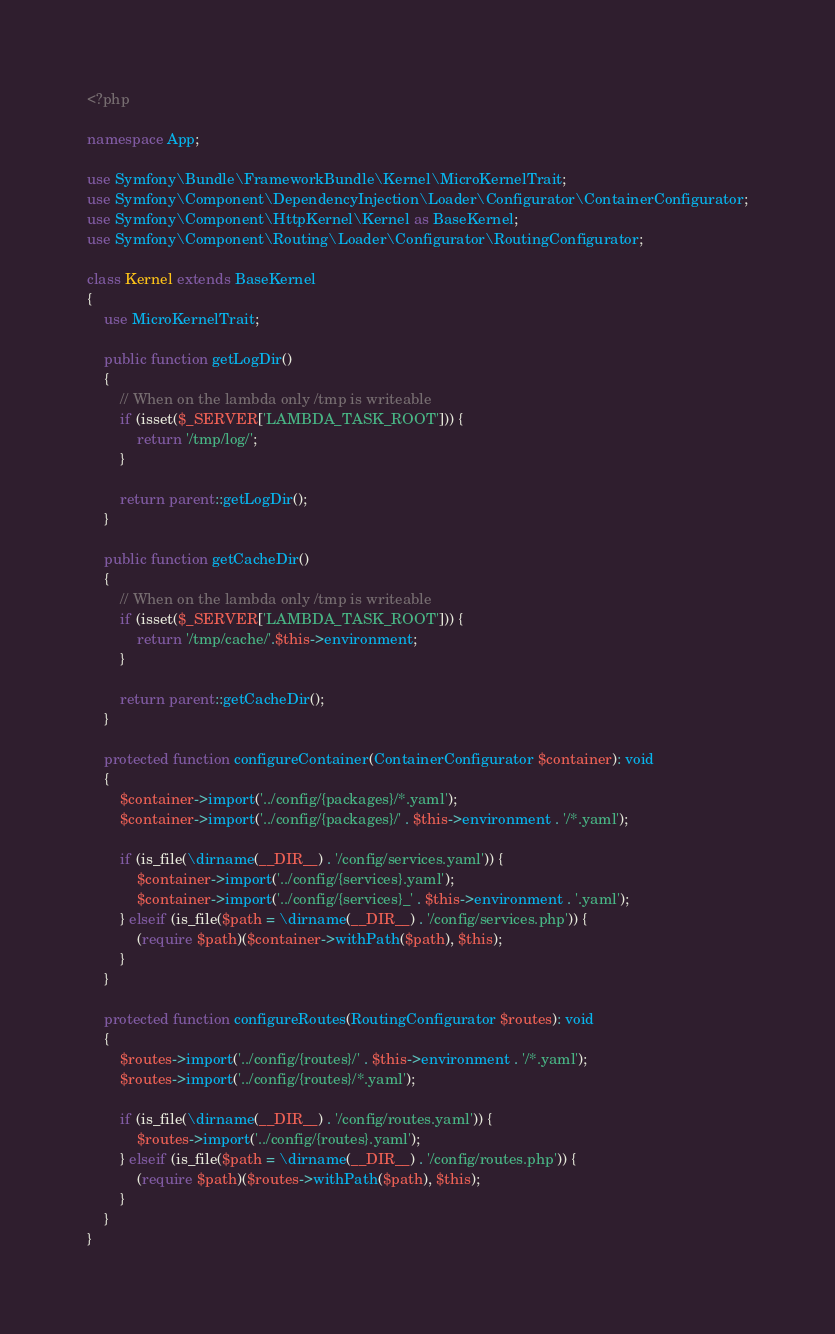Convert code to text. <code><loc_0><loc_0><loc_500><loc_500><_PHP_><?php

namespace App;

use Symfony\Bundle\FrameworkBundle\Kernel\MicroKernelTrait;
use Symfony\Component\DependencyInjection\Loader\Configurator\ContainerConfigurator;
use Symfony\Component\HttpKernel\Kernel as BaseKernel;
use Symfony\Component\Routing\Loader\Configurator\RoutingConfigurator;

class Kernel extends BaseKernel
{
    use MicroKernelTrait;

    public function getLogDir()
    {
        // When on the lambda only /tmp is writeable
        if (isset($_SERVER['LAMBDA_TASK_ROOT'])) {
            return '/tmp/log/';
        }

        return parent::getLogDir();
    }

    public function getCacheDir()
    {
        // When on the lambda only /tmp is writeable
        if (isset($_SERVER['LAMBDA_TASK_ROOT'])) {
            return '/tmp/cache/'.$this->environment;
        }

        return parent::getCacheDir();
    }

    protected function configureContainer(ContainerConfigurator $container): void
    {
        $container->import('../config/{packages}/*.yaml');
        $container->import('../config/{packages}/' . $this->environment . '/*.yaml');

        if (is_file(\dirname(__DIR__) . '/config/services.yaml')) {
            $container->import('../config/{services}.yaml');
            $container->import('../config/{services}_' . $this->environment . '.yaml');
        } elseif (is_file($path = \dirname(__DIR__) . '/config/services.php')) {
            (require $path)($container->withPath($path), $this);
        }
    }

    protected function configureRoutes(RoutingConfigurator $routes): void
    {
        $routes->import('../config/{routes}/' . $this->environment . '/*.yaml');
        $routes->import('../config/{routes}/*.yaml');

        if (is_file(\dirname(__DIR__) . '/config/routes.yaml')) {
            $routes->import('../config/{routes}.yaml');
        } elseif (is_file($path = \dirname(__DIR__) . '/config/routes.php')) {
            (require $path)($routes->withPath($path), $this);
        }
    }
}
</code> 